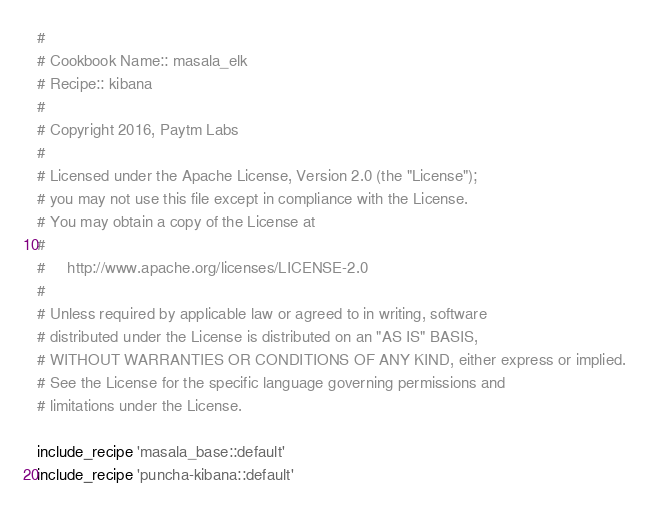Convert code to text. <code><loc_0><loc_0><loc_500><loc_500><_Ruby_>#
# Cookbook Name:: masala_elk
# Recipe:: kibana
#
# Copyright 2016, Paytm Labs
#
# Licensed under the Apache License, Version 2.0 (the "License");
# you may not use this file except in compliance with the License.
# You may obtain a copy of the License at
#
#     http://www.apache.org/licenses/LICENSE-2.0
#
# Unless required by applicable law or agreed to in writing, software
# distributed under the License is distributed on an "AS IS" BASIS,
# WITHOUT WARRANTIES OR CONDITIONS OF ANY KIND, either express or implied.
# See the License for the specific language governing permissions and
# limitations under the License.

include_recipe 'masala_base::default'
include_recipe 'puncha-kibana::default'

</code> 